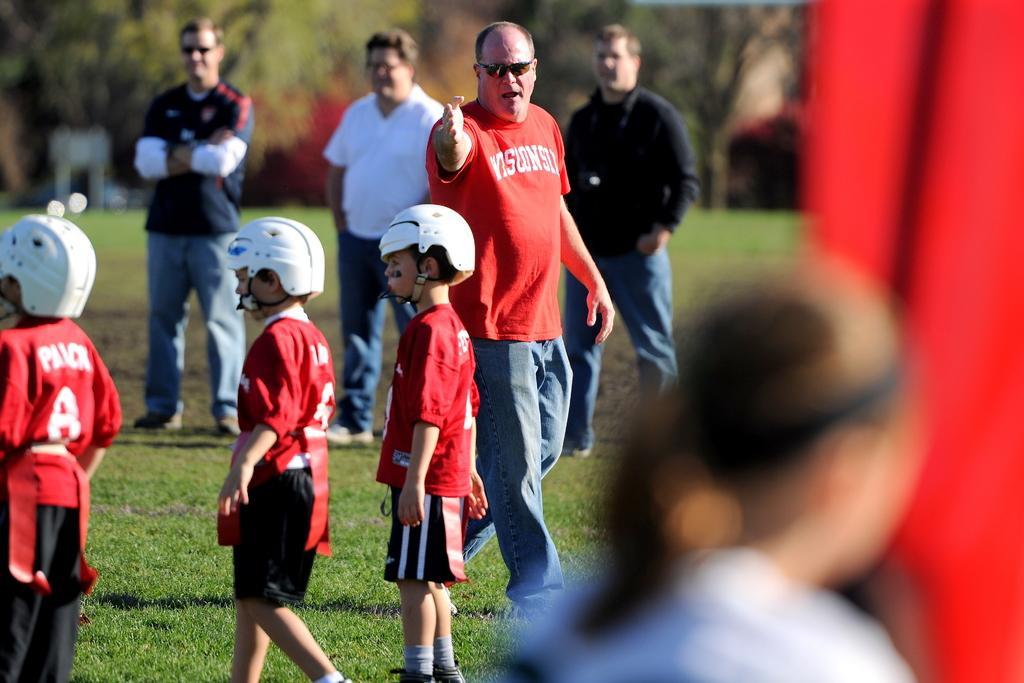Describe this image in one or two sentences. In this image we can see few people and there are three boys standing and wearing helmets. We can see some trees and grass on the ground and in the background and the image is blurred. 